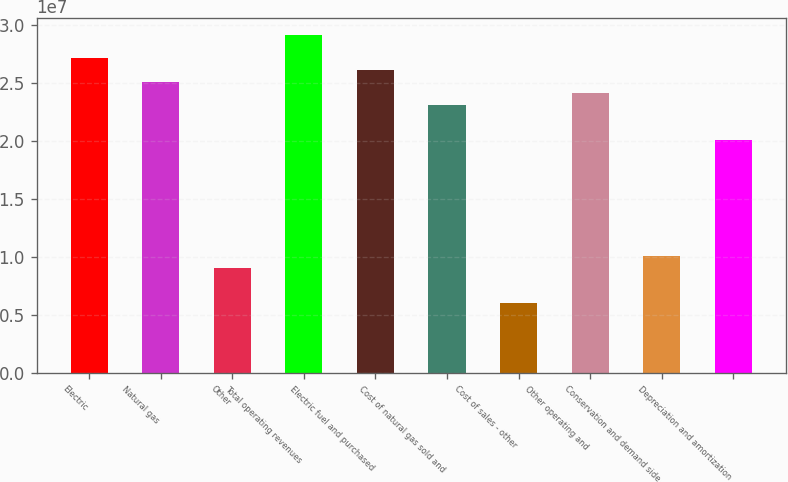Convert chart. <chart><loc_0><loc_0><loc_500><loc_500><bar_chart><fcel>Electric<fcel>Natural gas<fcel>Other<fcel>Total operating revenues<fcel>Electric fuel and purchased<fcel>Cost of natural gas sold and<fcel>Cost of sales - other<fcel>Other operating and<fcel>Conservation and demand side<fcel>Depreciation and amortization<nl><fcel>2.70923e+07<fcel>2.50854e+07<fcel>9.03075e+06<fcel>2.90991e+07<fcel>2.60888e+07<fcel>2.30786e+07<fcel>6.0205e+06<fcel>2.4082e+07<fcel>1.00342e+07<fcel>2.00683e+07<nl></chart> 